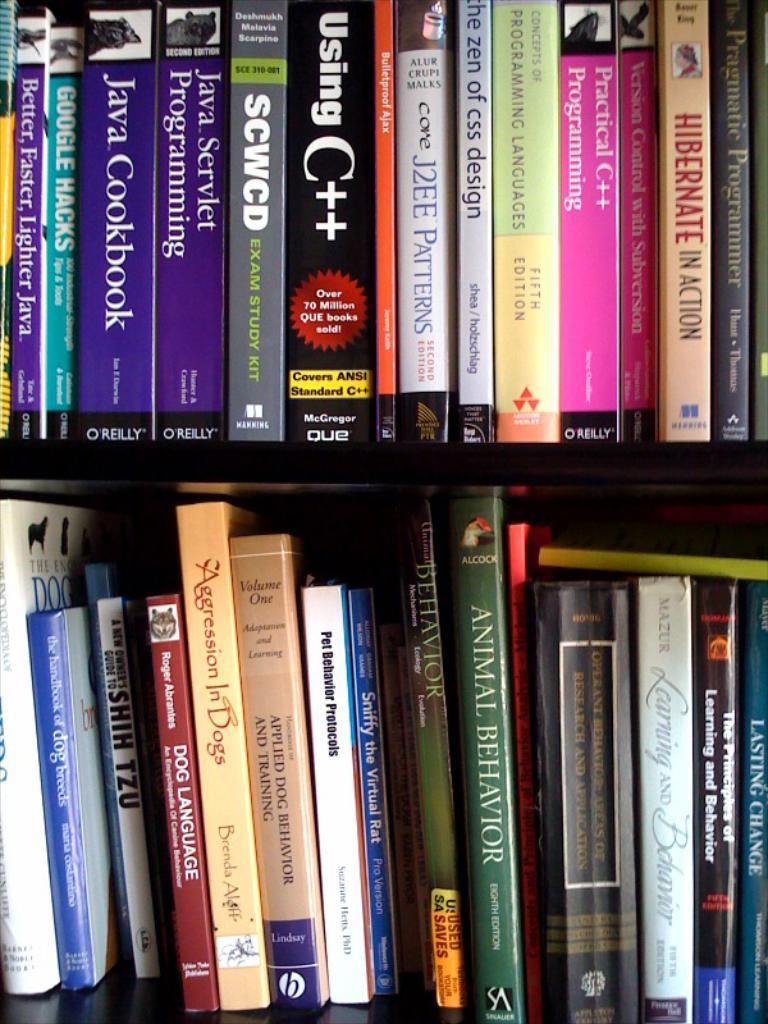What is the main subject of the image? The main subject of the image is many books. Where are the books located in the image? The books are in a rack. What can be seen on the books in the image? There is writing on the books. What time of day is it in the image? The time of day cannot be determined from the image, as there are no clues or indications of the time. 